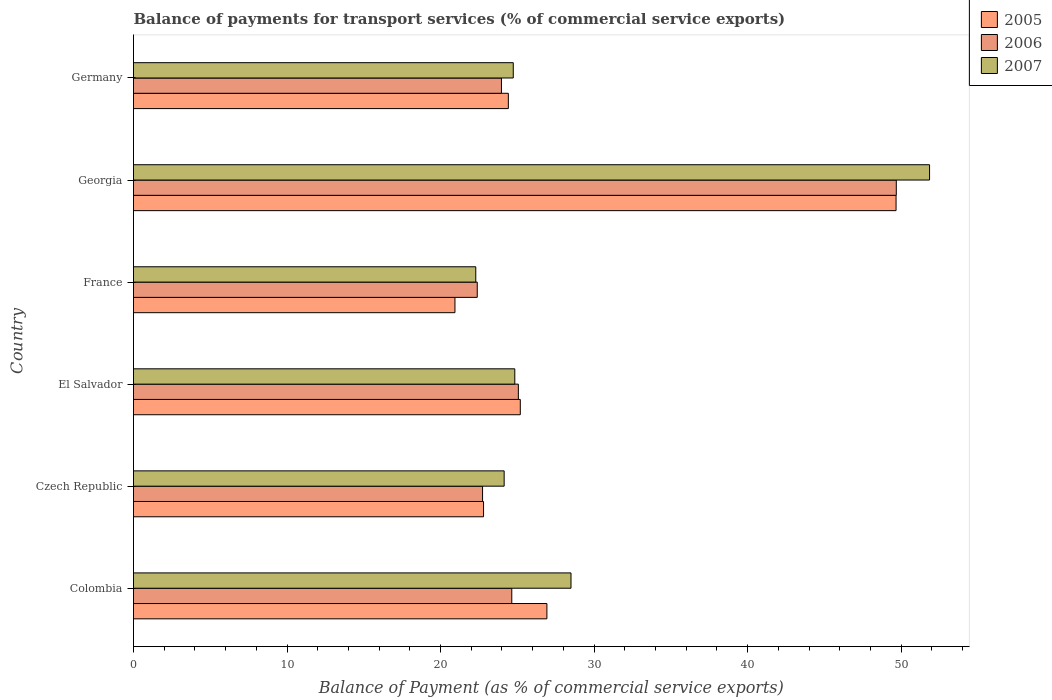How many different coloured bars are there?
Your answer should be compact. 3. Are the number of bars per tick equal to the number of legend labels?
Give a very brief answer. Yes. Are the number of bars on each tick of the Y-axis equal?
Keep it short and to the point. Yes. What is the label of the 3rd group of bars from the top?
Your response must be concise. France. In how many cases, is the number of bars for a given country not equal to the number of legend labels?
Your answer should be very brief. 0. What is the balance of payments for transport services in 2007 in Germany?
Provide a succinct answer. 24.74. Across all countries, what is the maximum balance of payments for transport services in 2006?
Make the answer very short. 49.69. Across all countries, what is the minimum balance of payments for transport services in 2005?
Offer a terse response. 20.94. In which country was the balance of payments for transport services in 2005 maximum?
Your answer should be compact. Georgia. What is the total balance of payments for transport services in 2007 in the graph?
Your answer should be compact. 176.36. What is the difference between the balance of payments for transport services in 2005 in Colombia and that in El Salvador?
Your response must be concise. 1.73. What is the difference between the balance of payments for transport services in 2006 in Colombia and the balance of payments for transport services in 2007 in Georgia?
Offer a terse response. -27.21. What is the average balance of payments for transport services in 2007 per country?
Your response must be concise. 29.39. What is the difference between the balance of payments for transport services in 2007 and balance of payments for transport services in 2006 in Colombia?
Keep it short and to the point. 3.86. What is the ratio of the balance of payments for transport services in 2006 in Czech Republic to that in El Salvador?
Make the answer very short. 0.91. Is the balance of payments for transport services in 2007 in El Salvador less than that in Georgia?
Your answer should be compact. Yes. Is the difference between the balance of payments for transport services in 2007 in Czech Republic and France greater than the difference between the balance of payments for transport services in 2006 in Czech Republic and France?
Make the answer very short. Yes. What is the difference between the highest and the second highest balance of payments for transport services in 2005?
Keep it short and to the point. 22.74. What is the difference between the highest and the lowest balance of payments for transport services in 2007?
Make the answer very short. 29.56. Is the sum of the balance of payments for transport services in 2007 in Czech Republic and El Salvador greater than the maximum balance of payments for transport services in 2006 across all countries?
Provide a succinct answer. No. What does the 2nd bar from the top in Colombia represents?
Give a very brief answer. 2006. Is it the case that in every country, the sum of the balance of payments for transport services in 2005 and balance of payments for transport services in 2007 is greater than the balance of payments for transport services in 2006?
Keep it short and to the point. Yes. How many countries are there in the graph?
Offer a very short reply. 6. Does the graph contain grids?
Offer a terse response. No. Where does the legend appear in the graph?
Give a very brief answer. Top right. How are the legend labels stacked?
Provide a succinct answer. Vertical. What is the title of the graph?
Offer a terse response. Balance of payments for transport services (% of commercial service exports). What is the label or title of the X-axis?
Keep it short and to the point. Balance of Payment (as % of commercial service exports). What is the label or title of the Y-axis?
Keep it short and to the point. Country. What is the Balance of Payment (as % of commercial service exports) of 2005 in Colombia?
Ensure brevity in your answer.  26.93. What is the Balance of Payment (as % of commercial service exports) of 2006 in Colombia?
Keep it short and to the point. 24.64. What is the Balance of Payment (as % of commercial service exports) in 2007 in Colombia?
Provide a short and direct response. 28.5. What is the Balance of Payment (as % of commercial service exports) in 2005 in Czech Republic?
Ensure brevity in your answer.  22.8. What is the Balance of Payment (as % of commercial service exports) in 2006 in Czech Republic?
Offer a very short reply. 22.74. What is the Balance of Payment (as % of commercial service exports) in 2007 in Czech Republic?
Give a very brief answer. 24.14. What is the Balance of Payment (as % of commercial service exports) in 2005 in El Salvador?
Offer a terse response. 25.19. What is the Balance of Payment (as % of commercial service exports) of 2006 in El Salvador?
Give a very brief answer. 25.07. What is the Balance of Payment (as % of commercial service exports) of 2007 in El Salvador?
Offer a terse response. 24.84. What is the Balance of Payment (as % of commercial service exports) of 2005 in France?
Make the answer very short. 20.94. What is the Balance of Payment (as % of commercial service exports) in 2006 in France?
Make the answer very short. 22.39. What is the Balance of Payment (as % of commercial service exports) in 2007 in France?
Provide a succinct answer. 22.29. What is the Balance of Payment (as % of commercial service exports) of 2005 in Georgia?
Offer a terse response. 49.67. What is the Balance of Payment (as % of commercial service exports) of 2006 in Georgia?
Make the answer very short. 49.69. What is the Balance of Payment (as % of commercial service exports) of 2007 in Georgia?
Provide a succinct answer. 51.85. What is the Balance of Payment (as % of commercial service exports) in 2005 in Germany?
Provide a short and direct response. 24.42. What is the Balance of Payment (as % of commercial service exports) in 2006 in Germany?
Make the answer very short. 23.97. What is the Balance of Payment (as % of commercial service exports) in 2007 in Germany?
Give a very brief answer. 24.74. Across all countries, what is the maximum Balance of Payment (as % of commercial service exports) of 2005?
Your answer should be very brief. 49.67. Across all countries, what is the maximum Balance of Payment (as % of commercial service exports) in 2006?
Make the answer very short. 49.69. Across all countries, what is the maximum Balance of Payment (as % of commercial service exports) in 2007?
Provide a short and direct response. 51.85. Across all countries, what is the minimum Balance of Payment (as % of commercial service exports) in 2005?
Keep it short and to the point. 20.94. Across all countries, what is the minimum Balance of Payment (as % of commercial service exports) in 2006?
Provide a succinct answer. 22.39. Across all countries, what is the minimum Balance of Payment (as % of commercial service exports) in 2007?
Provide a short and direct response. 22.29. What is the total Balance of Payment (as % of commercial service exports) in 2005 in the graph?
Provide a short and direct response. 169.95. What is the total Balance of Payment (as % of commercial service exports) in 2006 in the graph?
Offer a very short reply. 168.49. What is the total Balance of Payment (as % of commercial service exports) in 2007 in the graph?
Offer a terse response. 176.36. What is the difference between the Balance of Payment (as % of commercial service exports) of 2005 in Colombia and that in Czech Republic?
Offer a very short reply. 4.13. What is the difference between the Balance of Payment (as % of commercial service exports) in 2006 in Colombia and that in Czech Republic?
Your response must be concise. 1.9. What is the difference between the Balance of Payment (as % of commercial service exports) in 2007 in Colombia and that in Czech Republic?
Offer a very short reply. 4.35. What is the difference between the Balance of Payment (as % of commercial service exports) of 2005 in Colombia and that in El Salvador?
Keep it short and to the point. 1.73. What is the difference between the Balance of Payment (as % of commercial service exports) in 2006 in Colombia and that in El Salvador?
Provide a succinct answer. -0.43. What is the difference between the Balance of Payment (as % of commercial service exports) of 2007 in Colombia and that in El Salvador?
Your answer should be compact. 3.66. What is the difference between the Balance of Payment (as % of commercial service exports) of 2005 in Colombia and that in France?
Ensure brevity in your answer.  5.99. What is the difference between the Balance of Payment (as % of commercial service exports) of 2006 in Colombia and that in France?
Offer a very short reply. 2.25. What is the difference between the Balance of Payment (as % of commercial service exports) of 2007 in Colombia and that in France?
Ensure brevity in your answer.  6.2. What is the difference between the Balance of Payment (as % of commercial service exports) in 2005 in Colombia and that in Georgia?
Provide a succinct answer. -22.74. What is the difference between the Balance of Payment (as % of commercial service exports) in 2006 in Colombia and that in Georgia?
Offer a very short reply. -25.05. What is the difference between the Balance of Payment (as % of commercial service exports) in 2007 in Colombia and that in Georgia?
Offer a very short reply. -23.36. What is the difference between the Balance of Payment (as % of commercial service exports) in 2005 in Colombia and that in Germany?
Your answer should be very brief. 2.51. What is the difference between the Balance of Payment (as % of commercial service exports) in 2006 in Colombia and that in Germany?
Your answer should be very brief. 0.67. What is the difference between the Balance of Payment (as % of commercial service exports) in 2007 in Colombia and that in Germany?
Your response must be concise. 3.76. What is the difference between the Balance of Payment (as % of commercial service exports) in 2005 in Czech Republic and that in El Salvador?
Keep it short and to the point. -2.39. What is the difference between the Balance of Payment (as % of commercial service exports) in 2006 in Czech Republic and that in El Salvador?
Ensure brevity in your answer.  -2.33. What is the difference between the Balance of Payment (as % of commercial service exports) in 2007 in Czech Republic and that in El Salvador?
Give a very brief answer. -0.69. What is the difference between the Balance of Payment (as % of commercial service exports) in 2005 in Czech Republic and that in France?
Your answer should be compact. 1.86. What is the difference between the Balance of Payment (as % of commercial service exports) in 2006 in Czech Republic and that in France?
Give a very brief answer. 0.35. What is the difference between the Balance of Payment (as % of commercial service exports) in 2007 in Czech Republic and that in France?
Keep it short and to the point. 1.85. What is the difference between the Balance of Payment (as % of commercial service exports) of 2005 in Czech Republic and that in Georgia?
Offer a terse response. -26.87. What is the difference between the Balance of Payment (as % of commercial service exports) of 2006 in Czech Republic and that in Georgia?
Make the answer very short. -26.95. What is the difference between the Balance of Payment (as % of commercial service exports) in 2007 in Czech Republic and that in Georgia?
Keep it short and to the point. -27.71. What is the difference between the Balance of Payment (as % of commercial service exports) of 2005 in Czech Republic and that in Germany?
Your answer should be compact. -1.62. What is the difference between the Balance of Payment (as % of commercial service exports) in 2006 in Czech Republic and that in Germany?
Your response must be concise. -1.23. What is the difference between the Balance of Payment (as % of commercial service exports) in 2007 in Czech Republic and that in Germany?
Make the answer very short. -0.59. What is the difference between the Balance of Payment (as % of commercial service exports) in 2005 in El Salvador and that in France?
Offer a very short reply. 4.26. What is the difference between the Balance of Payment (as % of commercial service exports) in 2006 in El Salvador and that in France?
Your response must be concise. 2.68. What is the difference between the Balance of Payment (as % of commercial service exports) of 2007 in El Salvador and that in France?
Offer a terse response. 2.54. What is the difference between the Balance of Payment (as % of commercial service exports) of 2005 in El Salvador and that in Georgia?
Provide a succinct answer. -24.48. What is the difference between the Balance of Payment (as % of commercial service exports) of 2006 in El Salvador and that in Georgia?
Keep it short and to the point. -24.62. What is the difference between the Balance of Payment (as % of commercial service exports) of 2007 in El Salvador and that in Georgia?
Give a very brief answer. -27.02. What is the difference between the Balance of Payment (as % of commercial service exports) in 2006 in El Salvador and that in Germany?
Your answer should be compact. 1.1. What is the difference between the Balance of Payment (as % of commercial service exports) in 2007 in El Salvador and that in Germany?
Your response must be concise. 0.1. What is the difference between the Balance of Payment (as % of commercial service exports) in 2005 in France and that in Georgia?
Make the answer very short. -28.73. What is the difference between the Balance of Payment (as % of commercial service exports) of 2006 in France and that in Georgia?
Keep it short and to the point. -27.3. What is the difference between the Balance of Payment (as % of commercial service exports) in 2007 in France and that in Georgia?
Your response must be concise. -29.56. What is the difference between the Balance of Payment (as % of commercial service exports) of 2005 in France and that in Germany?
Your answer should be compact. -3.48. What is the difference between the Balance of Payment (as % of commercial service exports) of 2006 in France and that in Germany?
Provide a succinct answer. -1.58. What is the difference between the Balance of Payment (as % of commercial service exports) of 2007 in France and that in Germany?
Give a very brief answer. -2.44. What is the difference between the Balance of Payment (as % of commercial service exports) of 2005 in Georgia and that in Germany?
Your answer should be very brief. 25.25. What is the difference between the Balance of Payment (as % of commercial service exports) in 2006 in Georgia and that in Germany?
Your answer should be compact. 25.72. What is the difference between the Balance of Payment (as % of commercial service exports) of 2007 in Georgia and that in Germany?
Your answer should be very brief. 27.12. What is the difference between the Balance of Payment (as % of commercial service exports) of 2005 in Colombia and the Balance of Payment (as % of commercial service exports) of 2006 in Czech Republic?
Offer a very short reply. 4.19. What is the difference between the Balance of Payment (as % of commercial service exports) in 2005 in Colombia and the Balance of Payment (as % of commercial service exports) in 2007 in Czech Republic?
Your answer should be very brief. 2.78. What is the difference between the Balance of Payment (as % of commercial service exports) in 2006 in Colombia and the Balance of Payment (as % of commercial service exports) in 2007 in Czech Republic?
Keep it short and to the point. 0.5. What is the difference between the Balance of Payment (as % of commercial service exports) in 2005 in Colombia and the Balance of Payment (as % of commercial service exports) in 2006 in El Salvador?
Provide a short and direct response. 1.86. What is the difference between the Balance of Payment (as % of commercial service exports) in 2005 in Colombia and the Balance of Payment (as % of commercial service exports) in 2007 in El Salvador?
Your response must be concise. 2.09. What is the difference between the Balance of Payment (as % of commercial service exports) of 2006 in Colombia and the Balance of Payment (as % of commercial service exports) of 2007 in El Salvador?
Provide a succinct answer. -0.2. What is the difference between the Balance of Payment (as % of commercial service exports) of 2005 in Colombia and the Balance of Payment (as % of commercial service exports) of 2006 in France?
Make the answer very short. 4.54. What is the difference between the Balance of Payment (as % of commercial service exports) in 2005 in Colombia and the Balance of Payment (as % of commercial service exports) in 2007 in France?
Keep it short and to the point. 4.63. What is the difference between the Balance of Payment (as % of commercial service exports) in 2006 in Colombia and the Balance of Payment (as % of commercial service exports) in 2007 in France?
Give a very brief answer. 2.34. What is the difference between the Balance of Payment (as % of commercial service exports) of 2005 in Colombia and the Balance of Payment (as % of commercial service exports) of 2006 in Georgia?
Give a very brief answer. -22.76. What is the difference between the Balance of Payment (as % of commercial service exports) of 2005 in Colombia and the Balance of Payment (as % of commercial service exports) of 2007 in Georgia?
Provide a short and direct response. -24.93. What is the difference between the Balance of Payment (as % of commercial service exports) in 2006 in Colombia and the Balance of Payment (as % of commercial service exports) in 2007 in Georgia?
Give a very brief answer. -27.21. What is the difference between the Balance of Payment (as % of commercial service exports) of 2005 in Colombia and the Balance of Payment (as % of commercial service exports) of 2006 in Germany?
Provide a succinct answer. 2.96. What is the difference between the Balance of Payment (as % of commercial service exports) of 2005 in Colombia and the Balance of Payment (as % of commercial service exports) of 2007 in Germany?
Make the answer very short. 2.19. What is the difference between the Balance of Payment (as % of commercial service exports) in 2006 in Colombia and the Balance of Payment (as % of commercial service exports) in 2007 in Germany?
Your answer should be very brief. -0.1. What is the difference between the Balance of Payment (as % of commercial service exports) of 2005 in Czech Republic and the Balance of Payment (as % of commercial service exports) of 2006 in El Salvador?
Your answer should be very brief. -2.27. What is the difference between the Balance of Payment (as % of commercial service exports) in 2005 in Czech Republic and the Balance of Payment (as % of commercial service exports) in 2007 in El Salvador?
Your answer should be compact. -2.04. What is the difference between the Balance of Payment (as % of commercial service exports) of 2006 in Czech Republic and the Balance of Payment (as % of commercial service exports) of 2007 in El Salvador?
Offer a terse response. -2.1. What is the difference between the Balance of Payment (as % of commercial service exports) in 2005 in Czech Republic and the Balance of Payment (as % of commercial service exports) in 2006 in France?
Make the answer very short. 0.41. What is the difference between the Balance of Payment (as % of commercial service exports) in 2005 in Czech Republic and the Balance of Payment (as % of commercial service exports) in 2007 in France?
Provide a succinct answer. 0.51. What is the difference between the Balance of Payment (as % of commercial service exports) of 2006 in Czech Republic and the Balance of Payment (as % of commercial service exports) of 2007 in France?
Ensure brevity in your answer.  0.44. What is the difference between the Balance of Payment (as % of commercial service exports) in 2005 in Czech Republic and the Balance of Payment (as % of commercial service exports) in 2006 in Georgia?
Your answer should be compact. -26.89. What is the difference between the Balance of Payment (as % of commercial service exports) in 2005 in Czech Republic and the Balance of Payment (as % of commercial service exports) in 2007 in Georgia?
Provide a short and direct response. -29.05. What is the difference between the Balance of Payment (as % of commercial service exports) in 2006 in Czech Republic and the Balance of Payment (as % of commercial service exports) in 2007 in Georgia?
Provide a succinct answer. -29.12. What is the difference between the Balance of Payment (as % of commercial service exports) of 2005 in Czech Republic and the Balance of Payment (as % of commercial service exports) of 2006 in Germany?
Ensure brevity in your answer.  -1.17. What is the difference between the Balance of Payment (as % of commercial service exports) in 2005 in Czech Republic and the Balance of Payment (as % of commercial service exports) in 2007 in Germany?
Provide a short and direct response. -1.94. What is the difference between the Balance of Payment (as % of commercial service exports) of 2006 in Czech Republic and the Balance of Payment (as % of commercial service exports) of 2007 in Germany?
Make the answer very short. -2. What is the difference between the Balance of Payment (as % of commercial service exports) of 2005 in El Salvador and the Balance of Payment (as % of commercial service exports) of 2006 in France?
Offer a terse response. 2.8. What is the difference between the Balance of Payment (as % of commercial service exports) in 2005 in El Salvador and the Balance of Payment (as % of commercial service exports) in 2007 in France?
Keep it short and to the point. 2.9. What is the difference between the Balance of Payment (as % of commercial service exports) in 2006 in El Salvador and the Balance of Payment (as % of commercial service exports) in 2007 in France?
Keep it short and to the point. 2.77. What is the difference between the Balance of Payment (as % of commercial service exports) in 2005 in El Salvador and the Balance of Payment (as % of commercial service exports) in 2006 in Georgia?
Your response must be concise. -24.49. What is the difference between the Balance of Payment (as % of commercial service exports) of 2005 in El Salvador and the Balance of Payment (as % of commercial service exports) of 2007 in Georgia?
Make the answer very short. -26.66. What is the difference between the Balance of Payment (as % of commercial service exports) of 2006 in El Salvador and the Balance of Payment (as % of commercial service exports) of 2007 in Georgia?
Offer a terse response. -26.78. What is the difference between the Balance of Payment (as % of commercial service exports) of 2005 in El Salvador and the Balance of Payment (as % of commercial service exports) of 2006 in Germany?
Your answer should be compact. 1.23. What is the difference between the Balance of Payment (as % of commercial service exports) in 2005 in El Salvador and the Balance of Payment (as % of commercial service exports) in 2007 in Germany?
Offer a terse response. 0.46. What is the difference between the Balance of Payment (as % of commercial service exports) of 2006 in El Salvador and the Balance of Payment (as % of commercial service exports) of 2007 in Germany?
Your answer should be very brief. 0.33. What is the difference between the Balance of Payment (as % of commercial service exports) in 2005 in France and the Balance of Payment (as % of commercial service exports) in 2006 in Georgia?
Your answer should be very brief. -28.75. What is the difference between the Balance of Payment (as % of commercial service exports) in 2005 in France and the Balance of Payment (as % of commercial service exports) in 2007 in Georgia?
Provide a short and direct response. -30.91. What is the difference between the Balance of Payment (as % of commercial service exports) in 2006 in France and the Balance of Payment (as % of commercial service exports) in 2007 in Georgia?
Your answer should be very brief. -29.46. What is the difference between the Balance of Payment (as % of commercial service exports) of 2005 in France and the Balance of Payment (as % of commercial service exports) of 2006 in Germany?
Offer a terse response. -3.03. What is the difference between the Balance of Payment (as % of commercial service exports) of 2005 in France and the Balance of Payment (as % of commercial service exports) of 2007 in Germany?
Your answer should be very brief. -3.8. What is the difference between the Balance of Payment (as % of commercial service exports) in 2006 in France and the Balance of Payment (as % of commercial service exports) in 2007 in Germany?
Your answer should be compact. -2.35. What is the difference between the Balance of Payment (as % of commercial service exports) of 2005 in Georgia and the Balance of Payment (as % of commercial service exports) of 2006 in Germany?
Give a very brief answer. 25.7. What is the difference between the Balance of Payment (as % of commercial service exports) of 2005 in Georgia and the Balance of Payment (as % of commercial service exports) of 2007 in Germany?
Keep it short and to the point. 24.93. What is the difference between the Balance of Payment (as % of commercial service exports) of 2006 in Georgia and the Balance of Payment (as % of commercial service exports) of 2007 in Germany?
Offer a terse response. 24.95. What is the average Balance of Payment (as % of commercial service exports) of 2005 per country?
Your response must be concise. 28.32. What is the average Balance of Payment (as % of commercial service exports) in 2006 per country?
Provide a short and direct response. 28.08. What is the average Balance of Payment (as % of commercial service exports) of 2007 per country?
Offer a very short reply. 29.39. What is the difference between the Balance of Payment (as % of commercial service exports) in 2005 and Balance of Payment (as % of commercial service exports) in 2006 in Colombia?
Your answer should be compact. 2.29. What is the difference between the Balance of Payment (as % of commercial service exports) of 2005 and Balance of Payment (as % of commercial service exports) of 2007 in Colombia?
Keep it short and to the point. -1.57. What is the difference between the Balance of Payment (as % of commercial service exports) of 2006 and Balance of Payment (as % of commercial service exports) of 2007 in Colombia?
Your answer should be compact. -3.86. What is the difference between the Balance of Payment (as % of commercial service exports) of 2005 and Balance of Payment (as % of commercial service exports) of 2006 in Czech Republic?
Make the answer very short. 0.06. What is the difference between the Balance of Payment (as % of commercial service exports) in 2005 and Balance of Payment (as % of commercial service exports) in 2007 in Czech Republic?
Offer a terse response. -1.34. What is the difference between the Balance of Payment (as % of commercial service exports) of 2006 and Balance of Payment (as % of commercial service exports) of 2007 in Czech Republic?
Keep it short and to the point. -1.41. What is the difference between the Balance of Payment (as % of commercial service exports) in 2005 and Balance of Payment (as % of commercial service exports) in 2006 in El Salvador?
Make the answer very short. 0.13. What is the difference between the Balance of Payment (as % of commercial service exports) in 2005 and Balance of Payment (as % of commercial service exports) in 2007 in El Salvador?
Ensure brevity in your answer.  0.36. What is the difference between the Balance of Payment (as % of commercial service exports) of 2006 and Balance of Payment (as % of commercial service exports) of 2007 in El Salvador?
Provide a succinct answer. 0.23. What is the difference between the Balance of Payment (as % of commercial service exports) of 2005 and Balance of Payment (as % of commercial service exports) of 2006 in France?
Provide a short and direct response. -1.45. What is the difference between the Balance of Payment (as % of commercial service exports) of 2005 and Balance of Payment (as % of commercial service exports) of 2007 in France?
Keep it short and to the point. -1.36. What is the difference between the Balance of Payment (as % of commercial service exports) of 2006 and Balance of Payment (as % of commercial service exports) of 2007 in France?
Give a very brief answer. 0.1. What is the difference between the Balance of Payment (as % of commercial service exports) in 2005 and Balance of Payment (as % of commercial service exports) in 2006 in Georgia?
Make the answer very short. -0.02. What is the difference between the Balance of Payment (as % of commercial service exports) in 2005 and Balance of Payment (as % of commercial service exports) in 2007 in Georgia?
Ensure brevity in your answer.  -2.18. What is the difference between the Balance of Payment (as % of commercial service exports) in 2006 and Balance of Payment (as % of commercial service exports) in 2007 in Georgia?
Offer a terse response. -2.17. What is the difference between the Balance of Payment (as % of commercial service exports) of 2005 and Balance of Payment (as % of commercial service exports) of 2006 in Germany?
Provide a short and direct response. 0.45. What is the difference between the Balance of Payment (as % of commercial service exports) in 2005 and Balance of Payment (as % of commercial service exports) in 2007 in Germany?
Give a very brief answer. -0.32. What is the difference between the Balance of Payment (as % of commercial service exports) in 2006 and Balance of Payment (as % of commercial service exports) in 2007 in Germany?
Provide a short and direct response. -0.77. What is the ratio of the Balance of Payment (as % of commercial service exports) of 2005 in Colombia to that in Czech Republic?
Keep it short and to the point. 1.18. What is the ratio of the Balance of Payment (as % of commercial service exports) of 2006 in Colombia to that in Czech Republic?
Provide a succinct answer. 1.08. What is the ratio of the Balance of Payment (as % of commercial service exports) in 2007 in Colombia to that in Czech Republic?
Ensure brevity in your answer.  1.18. What is the ratio of the Balance of Payment (as % of commercial service exports) of 2005 in Colombia to that in El Salvador?
Your answer should be compact. 1.07. What is the ratio of the Balance of Payment (as % of commercial service exports) of 2006 in Colombia to that in El Salvador?
Give a very brief answer. 0.98. What is the ratio of the Balance of Payment (as % of commercial service exports) of 2007 in Colombia to that in El Salvador?
Your response must be concise. 1.15. What is the ratio of the Balance of Payment (as % of commercial service exports) of 2005 in Colombia to that in France?
Provide a short and direct response. 1.29. What is the ratio of the Balance of Payment (as % of commercial service exports) in 2006 in Colombia to that in France?
Your response must be concise. 1.1. What is the ratio of the Balance of Payment (as % of commercial service exports) of 2007 in Colombia to that in France?
Your answer should be very brief. 1.28. What is the ratio of the Balance of Payment (as % of commercial service exports) in 2005 in Colombia to that in Georgia?
Provide a succinct answer. 0.54. What is the ratio of the Balance of Payment (as % of commercial service exports) of 2006 in Colombia to that in Georgia?
Keep it short and to the point. 0.5. What is the ratio of the Balance of Payment (as % of commercial service exports) in 2007 in Colombia to that in Georgia?
Ensure brevity in your answer.  0.55. What is the ratio of the Balance of Payment (as % of commercial service exports) of 2005 in Colombia to that in Germany?
Give a very brief answer. 1.1. What is the ratio of the Balance of Payment (as % of commercial service exports) in 2006 in Colombia to that in Germany?
Your answer should be compact. 1.03. What is the ratio of the Balance of Payment (as % of commercial service exports) of 2007 in Colombia to that in Germany?
Your answer should be very brief. 1.15. What is the ratio of the Balance of Payment (as % of commercial service exports) in 2005 in Czech Republic to that in El Salvador?
Make the answer very short. 0.91. What is the ratio of the Balance of Payment (as % of commercial service exports) of 2006 in Czech Republic to that in El Salvador?
Keep it short and to the point. 0.91. What is the ratio of the Balance of Payment (as % of commercial service exports) of 2007 in Czech Republic to that in El Salvador?
Provide a succinct answer. 0.97. What is the ratio of the Balance of Payment (as % of commercial service exports) of 2005 in Czech Republic to that in France?
Make the answer very short. 1.09. What is the ratio of the Balance of Payment (as % of commercial service exports) of 2006 in Czech Republic to that in France?
Provide a succinct answer. 1.02. What is the ratio of the Balance of Payment (as % of commercial service exports) of 2007 in Czech Republic to that in France?
Your answer should be compact. 1.08. What is the ratio of the Balance of Payment (as % of commercial service exports) in 2005 in Czech Republic to that in Georgia?
Your response must be concise. 0.46. What is the ratio of the Balance of Payment (as % of commercial service exports) of 2006 in Czech Republic to that in Georgia?
Give a very brief answer. 0.46. What is the ratio of the Balance of Payment (as % of commercial service exports) of 2007 in Czech Republic to that in Georgia?
Give a very brief answer. 0.47. What is the ratio of the Balance of Payment (as % of commercial service exports) of 2005 in Czech Republic to that in Germany?
Provide a short and direct response. 0.93. What is the ratio of the Balance of Payment (as % of commercial service exports) in 2006 in Czech Republic to that in Germany?
Give a very brief answer. 0.95. What is the ratio of the Balance of Payment (as % of commercial service exports) in 2007 in Czech Republic to that in Germany?
Provide a succinct answer. 0.98. What is the ratio of the Balance of Payment (as % of commercial service exports) in 2005 in El Salvador to that in France?
Ensure brevity in your answer.  1.2. What is the ratio of the Balance of Payment (as % of commercial service exports) of 2006 in El Salvador to that in France?
Make the answer very short. 1.12. What is the ratio of the Balance of Payment (as % of commercial service exports) in 2007 in El Salvador to that in France?
Keep it short and to the point. 1.11. What is the ratio of the Balance of Payment (as % of commercial service exports) in 2005 in El Salvador to that in Georgia?
Give a very brief answer. 0.51. What is the ratio of the Balance of Payment (as % of commercial service exports) of 2006 in El Salvador to that in Georgia?
Provide a succinct answer. 0.5. What is the ratio of the Balance of Payment (as % of commercial service exports) of 2007 in El Salvador to that in Georgia?
Provide a succinct answer. 0.48. What is the ratio of the Balance of Payment (as % of commercial service exports) of 2005 in El Salvador to that in Germany?
Offer a terse response. 1.03. What is the ratio of the Balance of Payment (as % of commercial service exports) in 2006 in El Salvador to that in Germany?
Make the answer very short. 1.05. What is the ratio of the Balance of Payment (as % of commercial service exports) of 2007 in El Salvador to that in Germany?
Provide a succinct answer. 1. What is the ratio of the Balance of Payment (as % of commercial service exports) in 2005 in France to that in Georgia?
Give a very brief answer. 0.42. What is the ratio of the Balance of Payment (as % of commercial service exports) of 2006 in France to that in Georgia?
Keep it short and to the point. 0.45. What is the ratio of the Balance of Payment (as % of commercial service exports) in 2007 in France to that in Georgia?
Make the answer very short. 0.43. What is the ratio of the Balance of Payment (as % of commercial service exports) of 2005 in France to that in Germany?
Your answer should be compact. 0.86. What is the ratio of the Balance of Payment (as % of commercial service exports) in 2006 in France to that in Germany?
Keep it short and to the point. 0.93. What is the ratio of the Balance of Payment (as % of commercial service exports) of 2007 in France to that in Germany?
Your answer should be compact. 0.9. What is the ratio of the Balance of Payment (as % of commercial service exports) of 2005 in Georgia to that in Germany?
Your answer should be very brief. 2.03. What is the ratio of the Balance of Payment (as % of commercial service exports) in 2006 in Georgia to that in Germany?
Provide a short and direct response. 2.07. What is the ratio of the Balance of Payment (as % of commercial service exports) of 2007 in Georgia to that in Germany?
Offer a very short reply. 2.1. What is the difference between the highest and the second highest Balance of Payment (as % of commercial service exports) of 2005?
Keep it short and to the point. 22.74. What is the difference between the highest and the second highest Balance of Payment (as % of commercial service exports) of 2006?
Your answer should be very brief. 24.62. What is the difference between the highest and the second highest Balance of Payment (as % of commercial service exports) in 2007?
Keep it short and to the point. 23.36. What is the difference between the highest and the lowest Balance of Payment (as % of commercial service exports) of 2005?
Provide a succinct answer. 28.73. What is the difference between the highest and the lowest Balance of Payment (as % of commercial service exports) of 2006?
Provide a short and direct response. 27.3. What is the difference between the highest and the lowest Balance of Payment (as % of commercial service exports) of 2007?
Give a very brief answer. 29.56. 